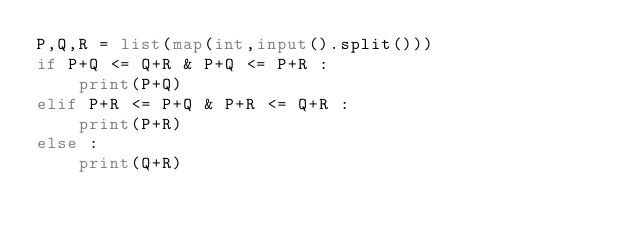<code> <loc_0><loc_0><loc_500><loc_500><_Python_>P,Q,R = list(map(int,input().split()))
if P+Q <= Q+R & P+Q <= P+R :
    print(P+Q)
elif P+R <= P+Q & P+R <= Q+R :
    print(P+R)
else :
    print(Q+R) 
</code> 